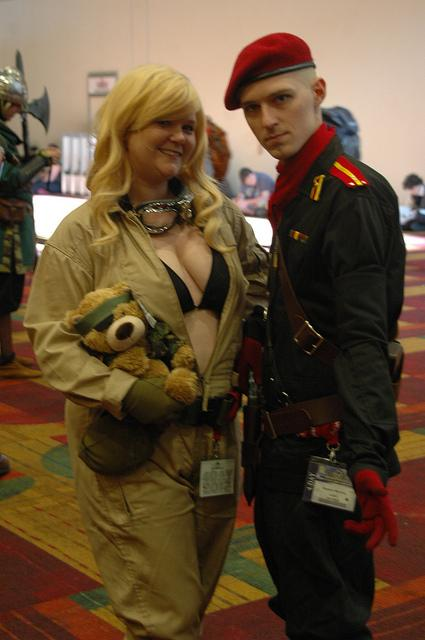What clothes are the people wearing? costume 